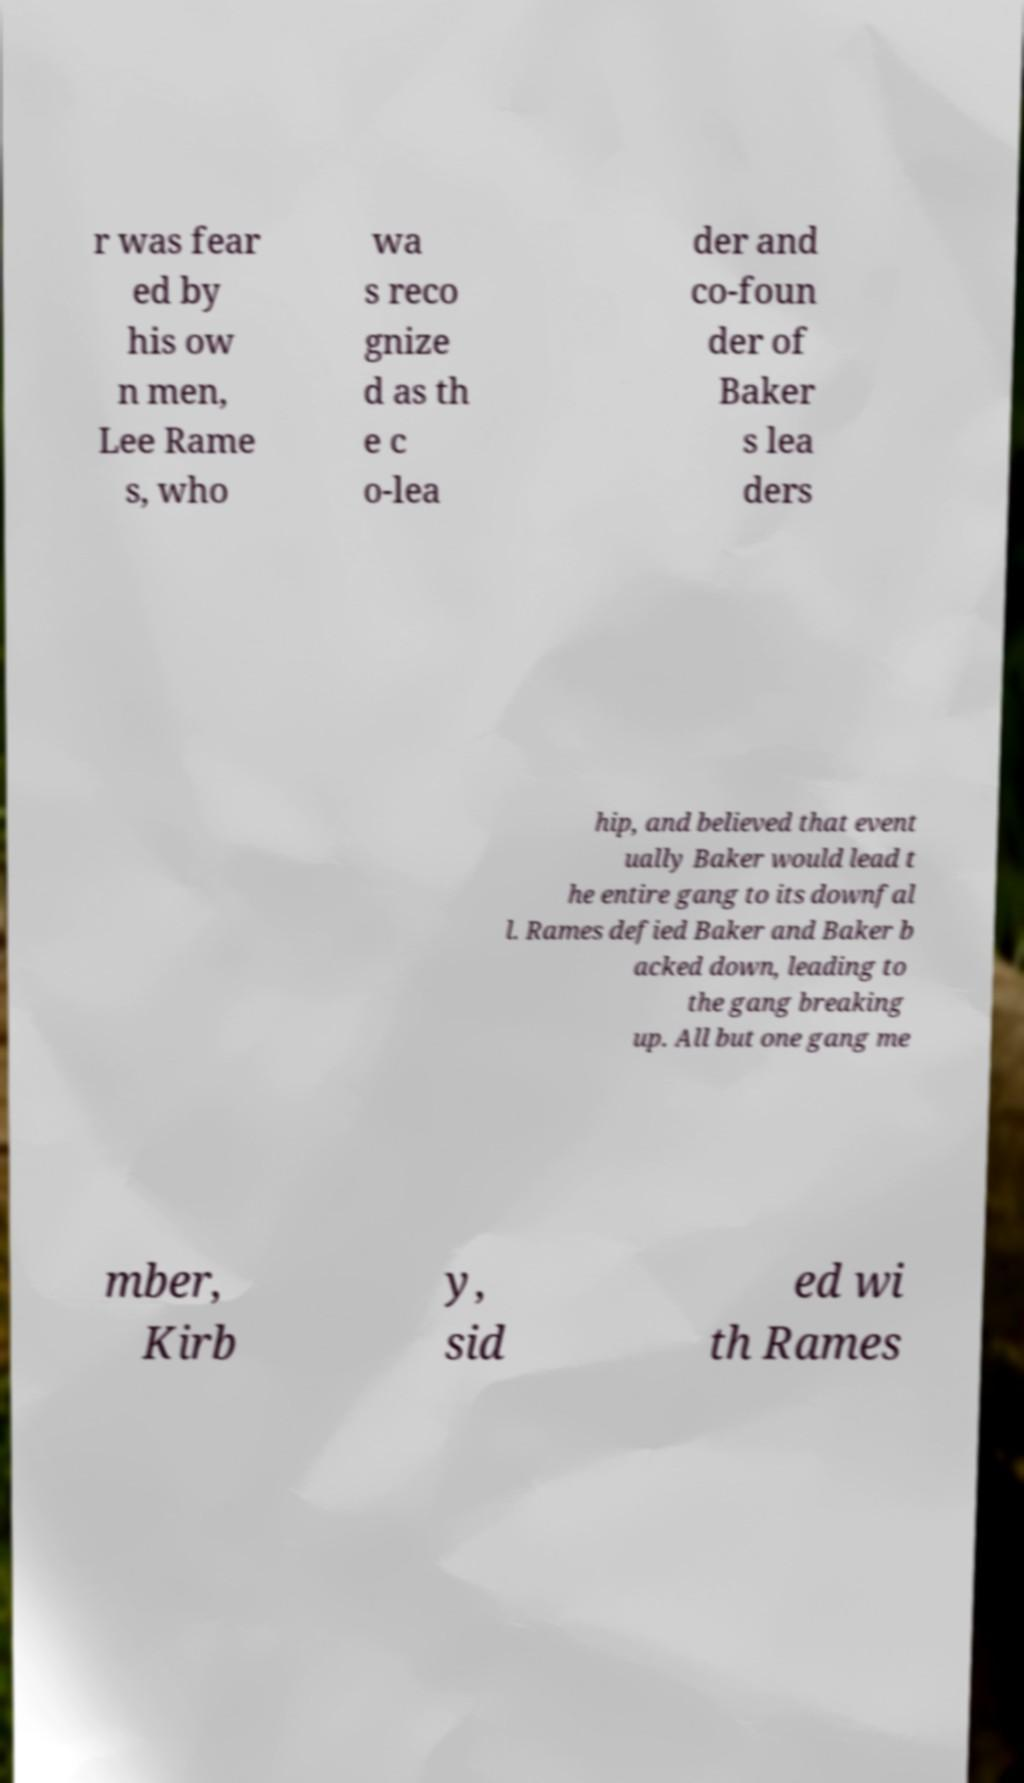Could you assist in decoding the text presented in this image and type it out clearly? r was fear ed by his ow n men, Lee Rame s, who wa s reco gnize d as th e c o-lea der and co-foun der of Baker s lea ders hip, and believed that event ually Baker would lead t he entire gang to its downfal l. Rames defied Baker and Baker b acked down, leading to the gang breaking up. All but one gang me mber, Kirb y, sid ed wi th Rames 